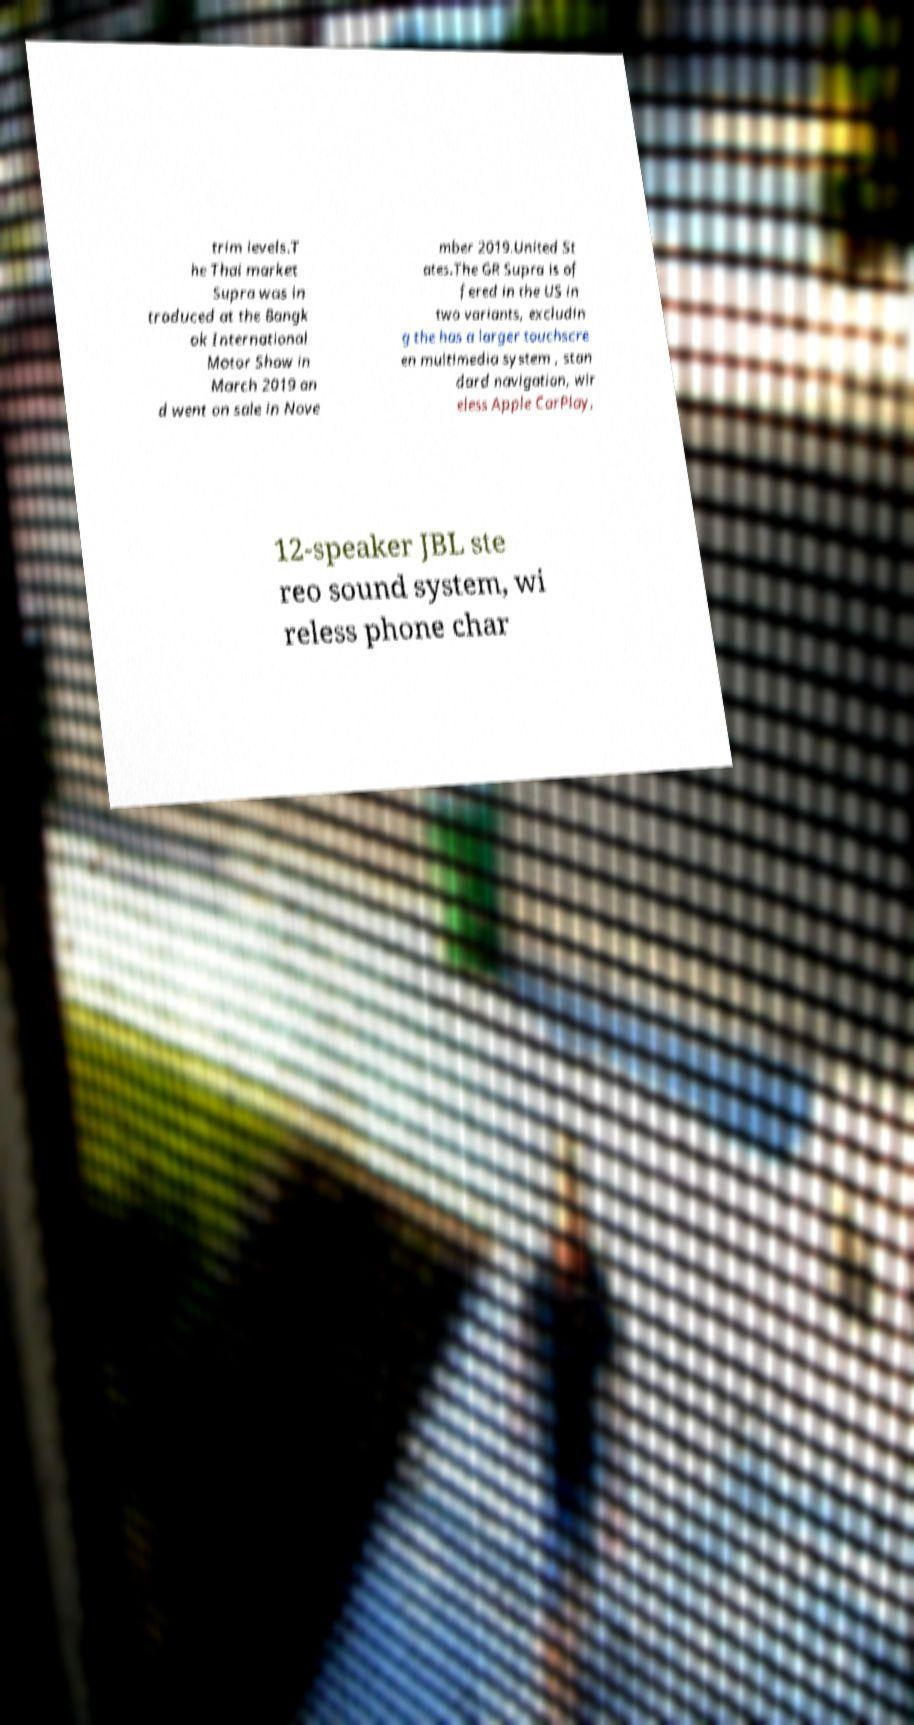Could you assist in decoding the text presented in this image and type it out clearly? trim levels.T he Thai market Supra was in troduced at the Bangk ok International Motor Show in March 2019 an d went on sale in Nove mber 2019.United St ates.The GR Supra is of fered in the US in two variants, excludin g the has a larger touchscre en multimedia system , stan dard navigation, wir eless Apple CarPlay, 12-speaker JBL ste reo sound system, wi reless phone char 